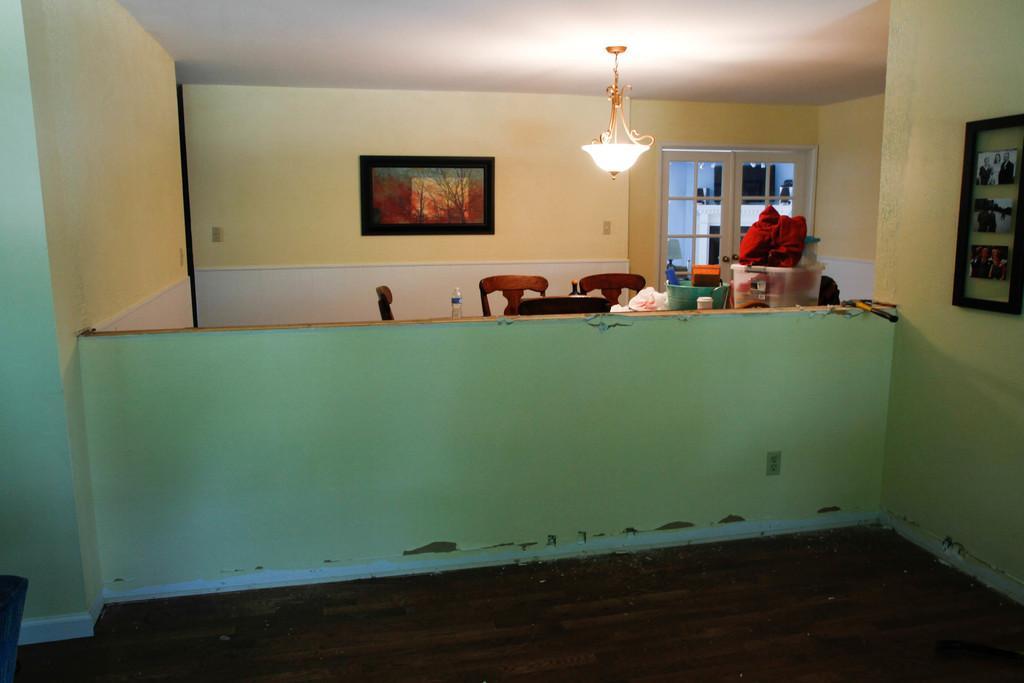Could you give a brief overview of what you see in this image? This is an indoor picture. Here we can see a wall with green colour. On the background we can see a door and a frame. This is a ceiling light. this is a bottle on the table. These are the chairs. here we can see baskets. This is a floor. 